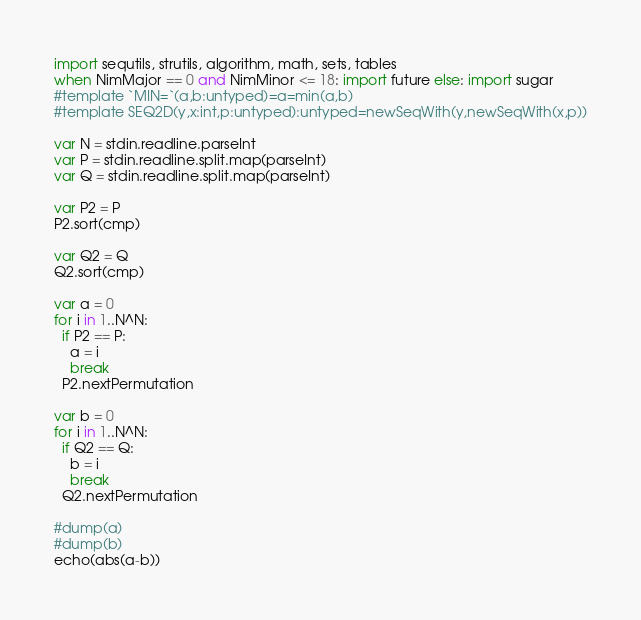<code> <loc_0><loc_0><loc_500><loc_500><_Nim_>import sequtils, strutils, algorithm, math, sets, tables
when NimMajor == 0 and NimMinor <= 18: import future else: import sugar
#template `MIN=`(a,b:untyped)=a=min(a,b)
#template SEQ2D(y,x:int,p:untyped):untyped=newSeqWith(y,newSeqWith(x,p))

var N = stdin.readline.parseInt
var P = stdin.readline.split.map(parseInt)
var Q = stdin.readline.split.map(parseInt)

var P2 = P
P2.sort(cmp)

var Q2 = Q
Q2.sort(cmp)

var a = 0
for i in 1..N^N:
  if P2 == P:
    a = i
    break
  P2.nextPermutation

var b = 0
for i in 1..N^N:
  if Q2 == Q:
    b = i
    break
  Q2.nextPermutation

#dump(a)
#dump(b)
echo(abs(a-b))
</code> 